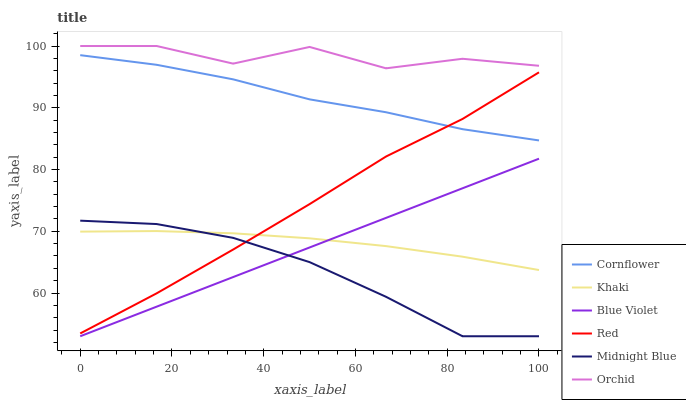Does Khaki have the minimum area under the curve?
Answer yes or no. No. Does Khaki have the maximum area under the curve?
Answer yes or no. No. Is Khaki the smoothest?
Answer yes or no. No. Is Khaki the roughest?
Answer yes or no. No. Does Khaki have the lowest value?
Answer yes or no. No. Does Midnight Blue have the highest value?
Answer yes or no. No. Is Cornflower less than Orchid?
Answer yes or no. Yes. Is Cornflower greater than Blue Violet?
Answer yes or no. Yes. Does Cornflower intersect Orchid?
Answer yes or no. No. 